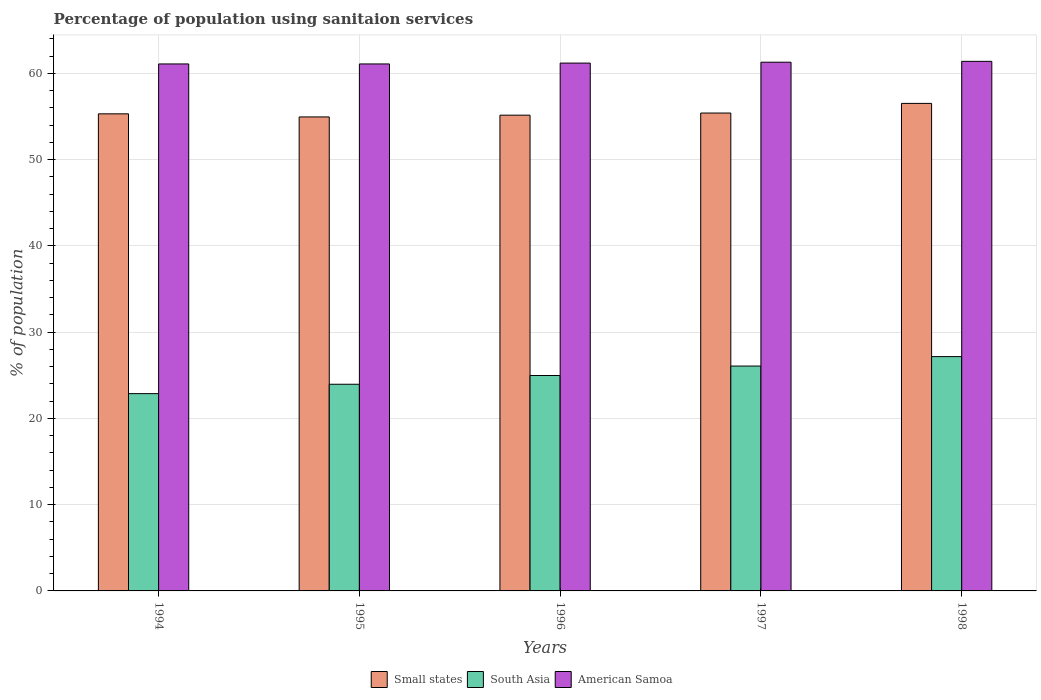What is the label of the 4th group of bars from the left?
Your answer should be very brief. 1997. In how many cases, is the number of bars for a given year not equal to the number of legend labels?
Make the answer very short. 0. What is the percentage of population using sanitaion services in American Samoa in 1996?
Give a very brief answer. 61.2. Across all years, what is the maximum percentage of population using sanitaion services in Small states?
Your answer should be compact. 56.52. Across all years, what is the minimum percentage of population using sanitaion services in Small states?
Your answer should be very brief. 54.96. In which year was the percentage of population using sanitaion services in Small states minimum?
Your response must be concise. 1995. What is the total percentage of population using sanitaion services in Small states in the graph?
Offer a very short reply. 277.37. What is the difference between the percentage of population using sanitaion services in Small states in 1994 and that in 1998?
Provide a short and direct response. -1.21. What is the difference between the percentage of population using sanitaion services in South Asia in 1998 and the percentage of population using sanitaion services in American Samoa in 1994?
Provide a short and direct response. -33.93. What is the average percentage of population using sanitaion services in Small states per year?
Your answer should be very brief. 55.47. In the year 1996, what is the difference between the percentage of population using sanitaion services in Small states and percentage of population using sanitaion services in South Asia?
Provide a succinct answer. 30.19. What is the ratio of the percentage of population using sanitaion services in South Asia in 1995 to that in 1997?
Your answer should be very brief. 0.92. What is the difference between the highest and the second highest percentage of population using sanitaion services in South Asia?
Provide a succinct answer. 1.1. What is the difference between the highest and the lowest percentage of population using sanitaion services in Small states?
Your answer should be compact. 1.57. In how many years, is the percentage of population using sanitaion services in American Samoa greater than the average percentage of population using sanitaion services in American Samoa taken over all years?
Make the answer very short. 2. What does the 3rd bar from the left in 1997 represents?
Your answer should be compact. American Samoa. Are all the bars in the graph horizontal?
Make the answer very short. No. What is the difference between two consecutive major ticks on the Y-axis?
Provide a short and direct response. 10. Are the values on the major ticks of Y-axis written in scientific E-notation?
Your response must be concise. No. Where does the legend appear in the graph?
Provide a short and direct response. Bottom center. How many legend labels are there?
Your response must be concise. 3. How are the legend labels stacked?
Provide a short and direct response. Horizontal. What is the title of the graph?
Offer a terse response. Percentage of population using sanitaion services. What is the label or title of the Y-axis?
Provide a short and direct response. % of population. What is the % of population in Small states in 1994?
Your response must be concise. 55.32. What is the % of population in South Asia in 1994?
Make the answer very short. 22.87. What is the % of population in American Samoa in 1994?
Your answer should be compact. 61.1. What is the % of population of Small states in 1995?
Keep it short and to the point. 54.96. What is the % of population of South Asia in 1995?
Your answer should be compact. 23.96. What is the % of population in American Samoa in 1995?
Make the answer very short. 61.1. What is the % of population in Small states in 1996?
Offer a very short reply. 55.16. What is the % of population of South Asia in 1996?
Ensure brevity in your answer.  24.98. What is the % of population of American Samoa in 1996?
Make the answer very short. 61.2. What is the % of population of Small states in 1997?
Your answer should be compact. 55.41. What is the % of population of South Asia in 1997?
Provide a succinct answer. 26.07. What is the % of population of American Samoa in 1997?
Provide a short and direct response. 61.3. What is the % of population of Small states in 1998?
Offer a very short reply. 56.52. What is the % of population in South Asia in 1998?
Provide a short and direct response. 27.17. What is the % of population in American Samoa in 1998?
Give a very brief answer. 61.4. Across all years, what is the maximum % of population in Small states?
Provide a succinct answer. 56.52. Across all years, what is the maximum % of population in South Asia?
Offer a very short reply. 27.17. Across all years, what is the maximum % of population in American Samoa?
Provide a short and direct response. 61.4. Across all years, what is the minimum % of population in Small states?
Your answer should be very brief. 54.96. Across all years, what is the minimum % of population of South Asia?
Your response must be concise. 22.87. Across all years, what is the minimum % of population in American Samoa?
Your answer should be compact. 61.1. What is the total % of population of Small states in the graph?
Your answer should be compact. 277.37. What is the total % of population of South Asia in the graph?
Your response must be concise. 125.05. What is the total % of population in American Samoa in the graph?
Offer a terse response. 306.1. What is the difference between the % of population of Small states in 1994 and that in 1995?
Provide a succinct answer. 0.36. What is the difference between the % of population of South Asia in 1994 and that in 1995?
Your answer should be compact. -1.09. What is the difference between the % of population in Small states in 1994 and that in 1996?
Provide a succinct answer. 0.15. What is the difference between the % of population of South Asia in 1994 and that in 1996?
Keep it short and to the point. -2.1. What is the difference between the % of population of Small states in 1994 and that in 1997?
Offer a terse response. -0.09. What is the difference between the % of population of South Asia in 1994 and that in 1997?
Offer a terse response. -3.2. What is the difference between the % of population in American Samoa in 1994 and that in 1997?
Provide a short and direct response. -0.2. What is the difference between the % of population of Small states in 1994 and that in 1998?
Offer a terse response. -1.21. What is the difference between the % of population of South Asia in 1994 and that in 1998?
Keep it short and to the point. -4.29. What is the difference between the % of population in Small states in 1995 and that in 1996?
Ensure brevity in your answer.  -0.2. What is the difference between the % of population of South Asia in 1995 and that in 1996?
Your answer should be compact. -1.01. What is the difference between the % of population of American Samoa in 1995 and that in 1996?
Your answer should be compact. -0.1. What is the difference between the % of population in Small states in 1995 and that in 1997?
Ensure brevity in your answer.  -0.45. What is the difference between the % of population in South Asia in 1995 and that in 1997?
Ensure brevity in your answer.  -2.11. What is the difference between the % of population in American Samoa in 1995 and that in 1997?
Ensure brevity in your answer.  -0.2. What is the difference between the % of population in Small states in 1995 and that in 1998?
Your response must be concise. -1.57. What is the difference between the % of population of South Asia in 1995 and that in 1998?
Offer a very short reply. -3.21. What is the difference between the % of population of Small states in 1996 and that in 1997?
Keep it short and to the point. -0.25. What is the difference between the % of population in South Asia in 1996 and that in 1997?
Your answer should be compact. -1.1. What is the difference between the % of population of American Samoa in 1996 and that in 1997?
Your response must be concise. -0.1. What is the difference between the % of population of Small states in 1996 and that in 1998?
Your answer should be compact. -1.36. What is the difference between the % of population in South Asia in 1996 and that in 1998?
Your answer should be very brief. -2.19. What is the difference between the % of population of Small states in 1997 and that in 1998?
Provide a short and direct response. -1.12. What is the difference between the % of population in South Asia in 1997 and that in 1998?
Provide a succinct answer. -1.1. What is the difference between the % of population of Small states in 1994 and the % of population of South Asia in 1995?
Your answer should be compact. 31.36. What is the difference between the % of population in Small states in 1994 and the % of population in American Samoa in 1995?
Your response must be concise. -5.78. What is the difference between the % of population of South Asia in 1994 and the % of population of American Samoa in 1995?
Offer a terse response. -38.23. What is the difference between the % of population in Small states in 1994 and the % of population in South Asia in 1996?
Provide a succinct answer. 30.34. What is the difference between the % of population in Small states in 1994 and the % of population in American Samoa in 1996?
Your response must be concise. -5.88. What is the difference between the % of population of South Asia in 1994 and the % of population of American Samoa in 1996?
Provide a succinct answer. -38.33. What is the difference between the % of population in Small states in 1994 and the % of population in South Asia in 1997?
Make the answer very short. 29.24. What is the difference between the % of population in Small states in 1994 and the % of population in American Samoa in 1997?
Offer a terse response. -5.98. What is the difference between the % of population in South Asia in 1994 and the % of population in American Samoa in 1997?
Provide a short and direct response. -38.43. What is the difference between the % of population of Small states in 1994 and the % of population of South Asia in 1998?
Offer a terse response. 28.15. What is the difference between the % of population in Small states in 1994 and the % of population in American Samoa in 1998?
Give a very brief answer. -6.08. What is the difference between the % of population in South Asia in 1994 and the % of population in American Samoa in 1998?
Your answer should be very brief. -38.53. What is the difference between the % of population of Small states in 1995 and the % of population of South Asia in 1996?
Keep it short and to the point. 29.98. What is the difference between the % of population in Small states in 1995 and the % of population in American Samoa in 1996?
Make the answer very short. -6.24. What is the difference between the % of population in South Asia in 1995 and the % of population in American Samoa in 1996?
Your response must be concise. -37.24. What is the difference between the % of population in Small states in 1995 and the % of population in South Asia in 1997?
Offer a very short reply. 28.88. What is the difference between the % of population of Small states in 1995 and the % of population of American Samoa in 1997?
Make the answer very short. -6.34. What is the difference between the % of population of South Asia in 1995 and the % of population of American Samoa in 1997?
Offer a terse response. -37.34. What is the difference between the % of population in Small states in 1995 and the % of population in South Asia in 1998?
Offer a very short reply. 27.79. What is the difference between the % of population in Small states in 1995 and the % of population in American Samoa in 1998?
Keep it short and to the point. -6.44. What is the difference between the % of population in South Asia in 1995 and the % of population in American Samoa in 1998?
Provide a succinct answer. -37.44. What is the difference between the % of population of Small states in 1996 and the % of population of South Asia in 1997?
Your answer should be very brief. 29.09. What is the difference between the % of population in Small states in 1996 and the % of population in American Samoa in 1997?
Your answer should be compact. -6.14. What is the difference between the % of population of South Asia in 1996 and the % of population of American Samoa in 1997?
Your answer should be compact. -36.32. What is the difference between the % of population in Small states in 1996 and the % of population in South Asia in 1998?
Offer a very short reply. 27.99. What is the difference between the % of population of Small states in 1996 and the % of population of American Samoa in 1998?
Keep it short and to the point. -6.24. What is the difference between the % of population of South Asia in 1996 and the % of population of American Samoa in 1998?
Your answer should be compact. -36.42. What is the difference between the % of population of Small states in 1997 and the % of population of South Asia in 1998?
Offer a very short reply. 28.24. What is the difference between the % of population in Small states in 1997 and the % of population in American Samoa in 1998?
Offer a very short reply. -5.99. What is the difference between the % of population of South Asia in 1997 and the % of population of American Samoa in 1998?
Offer a terse response. -35.33. What is the average % of population in Small states per year?
Keep it short and to the point. 55.47. What is the average % of population in South Asia per year?
Your answer should be very brief. 25.01. What is the average % of population of American Samoa per year?
Offer a very short reply. 61.22. In the year 1994, what is the difference between the % of population of Small states and % of population of South Asia?
Provide a succinct answer. 32.44. In the year 1994, what is the difference between the % of population in Small states and % of population in American Samoa?
Keep it short and to the point. -5.78. In the year 1994, what is the difference between the % of population of South Asia and % of population of American Samoa?
Your answer should be very brief. -38.23. In the year 1995, what is the difference between the % of population in Small states and % of population in South Asia?
Make the answer very short. 31. In the year 1995, what is the difference between the % of population in Small states and % of population in American Samoa?
Provide a short and direct response. -6.14. In the year 1995, what is the difference between the % of population of South Asia and % of population of American Samoa?
Make the answer very short. -37.14. In the year 1996, what is the difference between the % of population of Small states and % of population of South Asia?
Offer a terse response. 30.19. In the year 1996, what is the difference between the % of population of Small states and % of population of American Samoa?
Your response must be concise. -6.04. In the year 1996, what is the difference between the % of population in South Asia and % of population in American Samoa?
Keep it short and to the point. -36.22. In the year 1997, what is the difference between the % of population of Small states and % of population of South Asia?
Your answer should be compact. 29.34. In the year 1997, what is the difference between the % of population of Small states and % of population of American Samoa?
Give a very brief answer. -5.89. In the year 1997, what is the difference between the % of population in South Asia and % of population in American Samoa?
Provide a succinct answer. -35.23. In the year 1998, what is the difference between the % of population in Small states and % of population in South Asia?
Offer a terse response. 29.36. In the year 1998, what is the difference between the % of population in Small states and % of population in American Samoa?
Your response must be concise. -4.88. In the year 1998, what is the difference between the % of population in South Asia and % of population in American Samoa?
Your response must be concise. -34.23. What is the ratio of the % of population of Small states in 1994 to that in 1995?
Offer a very short reply. 1.01. What is the ratio of the % of population of South Asia in 1994 to that in 1995?
Make the answer very short. 0.95. What is the ratio of the % of population of Small states in 1994 to that in 1996?
Offer a terse response. 1. What is the ratio of the % of population of South Asia in 1994 to that in 1996?
Make the answer very short. 0.92. What is the ratio of the % of population of American Samoa in 1994 to that in 1996?
Ensure brevity in your answer.  1. What is the ratio of the % of population of South Asia in 1994 to that in 1997?
Your response must be concise. 0.88. What is the ratio of the % of population of Small states in 1994 to that in 1998?
Your response must be concise. 0.98. What is the ratio of the % of population of South Asia in 1994 to that in 1998?
Offer a very short reply. 0.84. What is the ratio of the % of population of American Samoa in 1994 to that in 1998?
Your answer should be very brief. 1. What is the ratio of the % of population of Small states in 1995 to that in 1996?
Provide a short and direct response. 1. What is the ratio of the % of population of South Asia in 1995 to that in 1996?
Make the answer very short. 0.96. What is the ratio of the % of population in South Asia in 1995 to that in 1997?
Offer a very short reply. 0.92. What is the ratio of the % of population of Small states in 1995 to that in 1998?
Keep it short and to the point. 0.97. What is the ratio of the % of population in South Asia in 1995 to that in 1998?
Provide a succinct answer. 0.88. What is the ratio of the % of population in American Samoa in 1995 to that in 1998?
Your answer should be compact. 1. What is the ratio of the % of population in South Asia in 1996 to that in 1997?
Provide a short and direct response. 0.96. What is the ratio of the % of population in Small states in 1996 to that in 1998?
Provide a succinct answer. 0.98. What is the ratio of the % of population in South Asia in 1996 to that in 1998?
Keep it short and to the point. 0.92. What is the ratio of the % of population of American Samoa in 1996 to that in 1998?
Provide a succinct answer. 1. What is the ratio of the % of population of Small states in 1997 to that in 1998?
Offer a terse response. 0.98. What is the ratio of the % of population in South Asia in 1997 to that in 1998?
Provide a short and direct response. 0.96. What is the difference between the highest and the second highest % of population in Small states?
Your response must be concise. 1.12. What is the difference between the highest and the second highest % of population in South Asia?
Ensure brevity in your answer.  1.1. What is the difference between the highest and the lowest % of population of Small states?
Make the answer very short. 1.57. What is the difference between the highest and the lowest % of population of South Asia?
Give a very brief answer. 4.29. What is the difference between the highest and the lowest % of population in American Samoa?
Give a very brief answer. 0.3. 